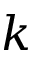Convert formula to latex. <formula><loc_0><loc_0><loc_500><loc_500>k</formula> 